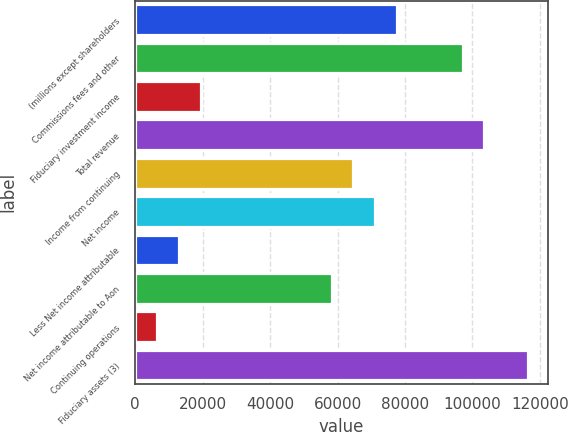Convert chart to OTSL. <chart><loc_0><loc_0><loc_500><loc_500><bar_chart><fcel>(millions except shareholders<fcel>Commissions fees and other<fcel>Fiduciary investment income<fcel>Total revenue<fcel>Income from continuing<fcel>Net income<fcel>Less Net income attributable<fcel>Net income attributable to Aon<fcel>Continuing operations<fcel>Fiduciary assets (3)<nl><fcel>77669.9<fcel>97087.2<fcel>19417.9<fcel>103560<fcel>64725<fcel>71197.5<fcel>12945.5<fcel>58252.6<fcel>6473.06<fcel>116505<nl></chart> 